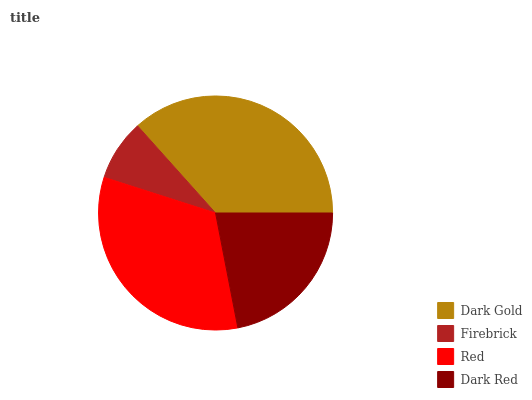Is Firebrick the minimum?
Answer yes or no. Yes. Is Dark Gold the maximum?
Answer yes or no. Yes. Is Red the minimum?
Answer yes or no. No. Is Red the maximum?
Answer yes or no. No. Is Red greater than Firebrick?
Answer yes or no. Yes. Is Firebrick less than Red?
Answer yes or no. Yes. Is Firebrick greater than Red?
Answer yes or no. No. Is Red less than Firebrick?
Answer yes or no. No. Is Red the high median?
Answer yes or no. Yes. Is Dark Red the low median?
Answer yes or no. Yes. Is Dark Gold the high median?
Answer yes or no. No. Is Red the low median?
Answer yes or no. No. 